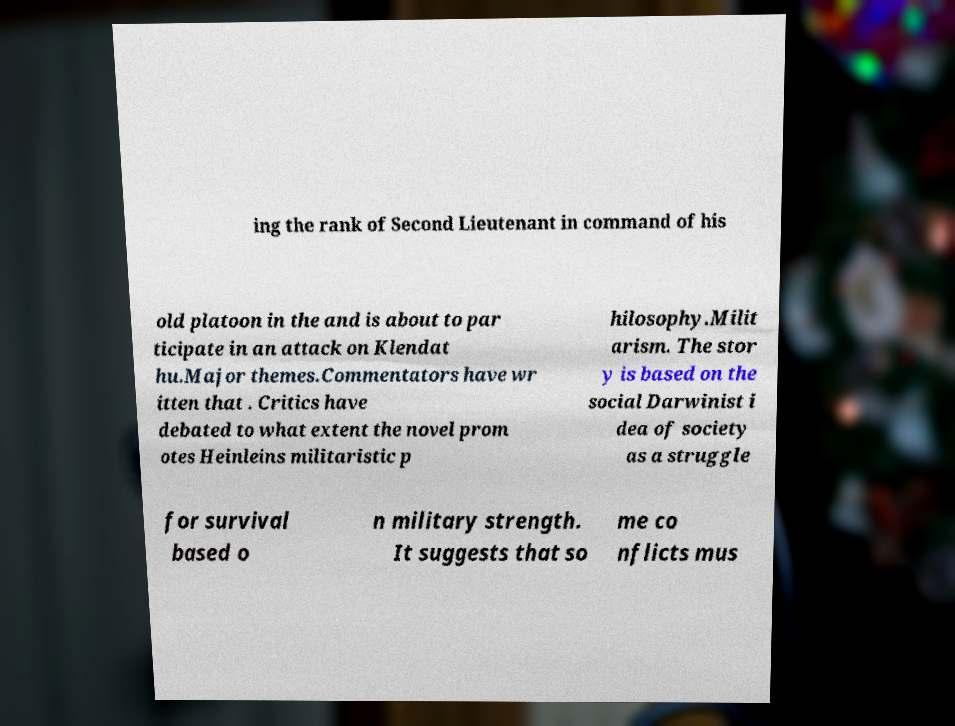Please read and relay the text visible in this image. What does it say? ing the rank of Second Lieutenant in command of his old platoon in the and is about to par ticipate in an attack on Klendat hu.Major themes.Commentators have wr itten that . Critics have debated to what extent the novel prom otes Heinleins militaristic p hilosophy.Milit arism. The stor y is based on the social Darwinist i dea of society as a struggle for survival based o n military strength. It suggests that so me co nflicts mus 